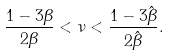<formula> <loc_0><loc_0><loc_500><loc_500>\frac { 1 - 3 \beta } { 2 \beta } < \nu < \frac { 1 - 3 \hat { \beta } } { 2 \hat { \beta } } .</formula> 